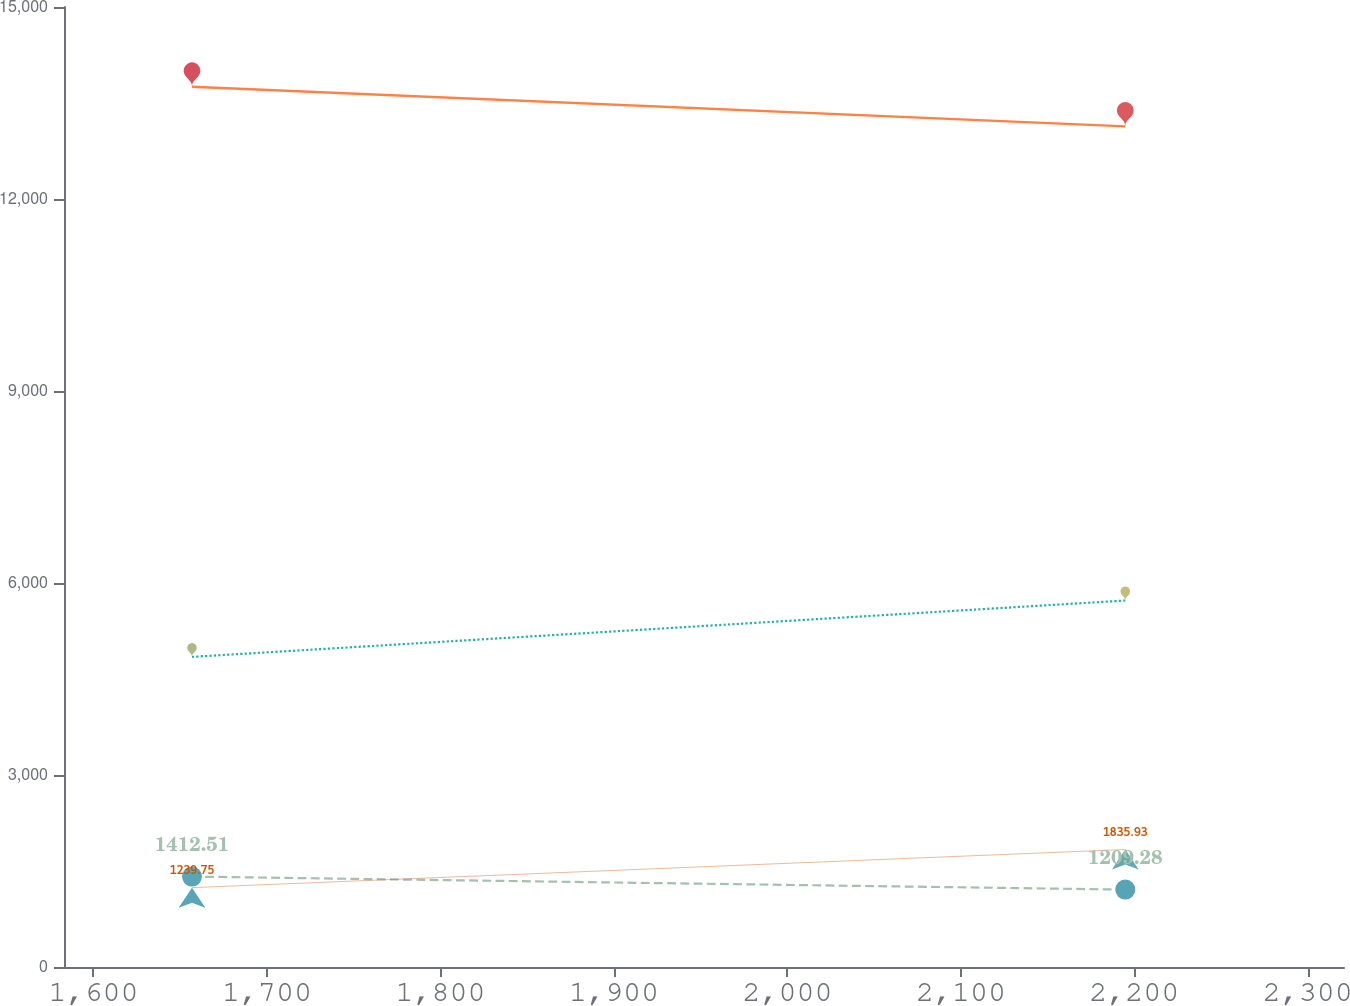Convert chart to OTSL. <chart><loc_0><loc_0><loc_500><loc_500><line_chart><ecel><fcel>Asia Pacific<fcel>Americas other than U.S.<fcel>United States<fcel>United Kingdom<nl><fcel>1656.81<fcel>13754.1<fcel>4845.62<fcel>1412.51<fcel>1239.75<nl><fcel>2194.77<fcel>13135.2<fcel>5726.4<fcel>1209.28<fcel>1835.93<nl><fcel>2394.61<fcel>9581<fcel>5363.9<fcel>944.58<fcel>1718.83<nl></chart> 